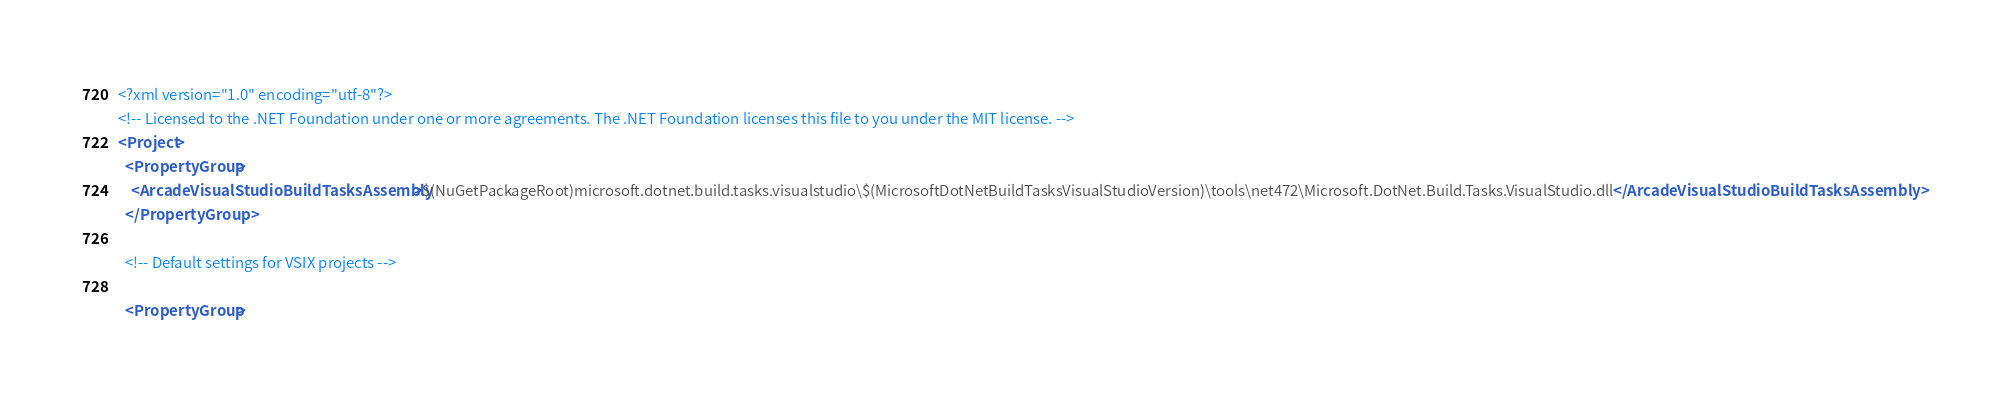<code> <loc_0><loc_0><loc_500><loc_500><_XML_><?xml version="1.0" encoding="utf-8"?>
<!-- Licensed to the .NET Foundation under one or more agreements. The .NET Foundation licenses this file to you under the MIT license. -->
<Project>
  <PropertyGroup>
    <ArcadeVisualStudioBuildTasksAssembly>$(NuGetPackageRoot)microsoft.dotnet.build.tasks.visualstudio\$(MicrosoftDotNetBuildTasksVisualStudioVersion)\tools\net472\Microsoft.DotNet.Build.Tasks.VisualStudio.dll</ArcadeVisualStudioBuildTasksAssembly>
  </PropertyGroup>

  <!-- Default settings for VSIX projects -->

  <PropertyGroup></code> 